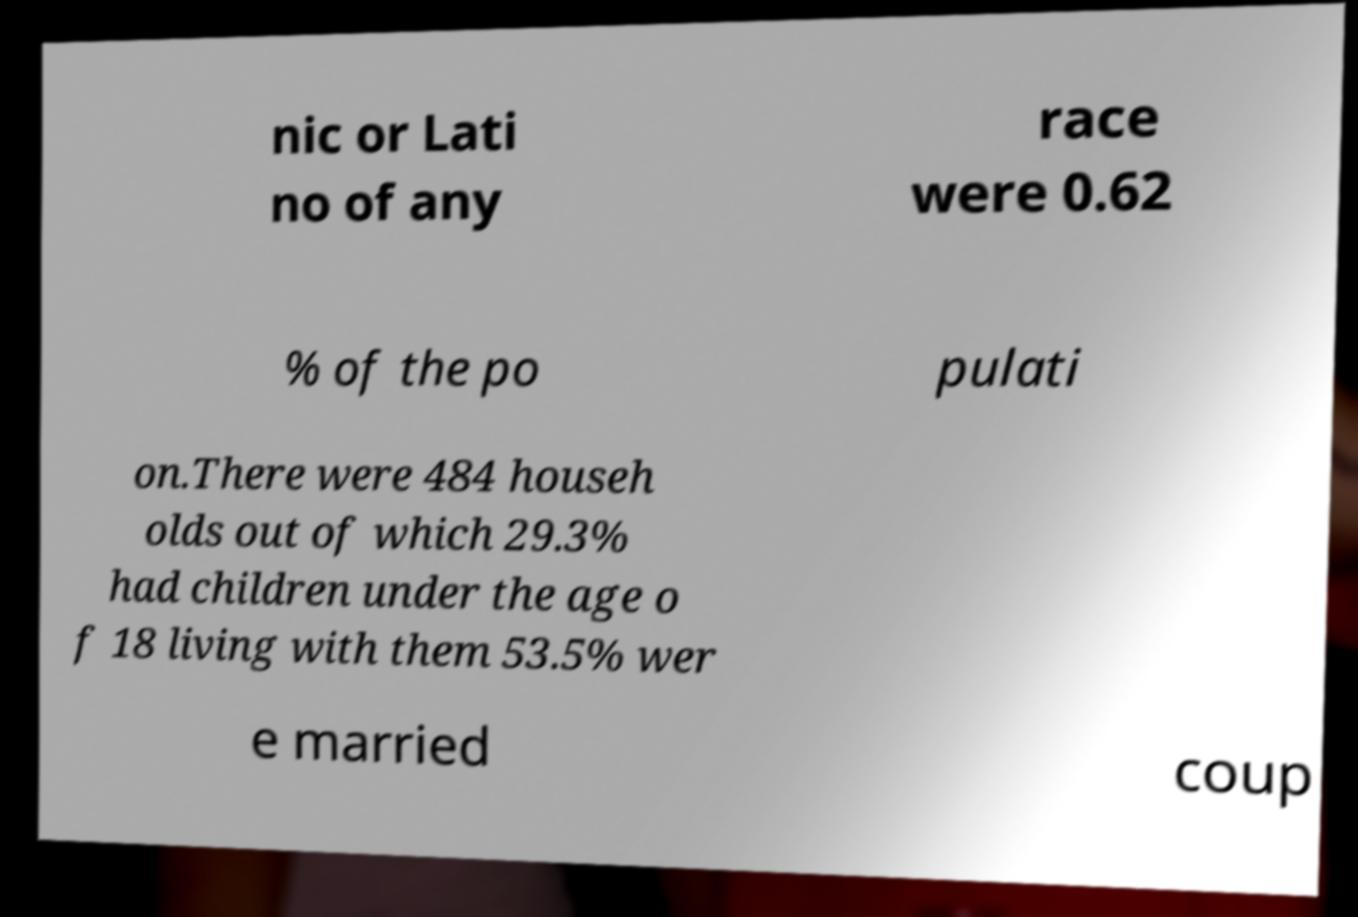There's text embedded in this image that I need extracted. Can you transcribe it verbatim? nic or Lati no of any race were 0.62 % of the po pulati on.There were 484 househ olds out of which 29.3% had children under the age o f 18 living with them 53.5% wer e married coup 